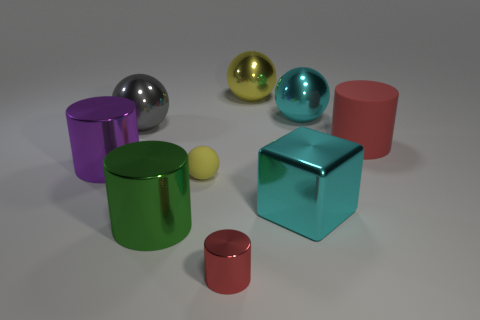Are there fewer red shiny cylinders than big blue shiny cylinders?
Make the answer very short. No. There is a gray ball; does it have the same size as the red cylinder on the left side of the cyan metallic cube?
Your answer should be very brief. No. What color is the ball in front of the cylinder that is on the right side of the big cyan cube?
Your response must be concise. Yellow. What number of objects are purple things that are behind the large cyan block or shiny spheres that are to the left of the block?
Ensure brevity in your answer.  3. Does the purple metallic cylinder have the same size as the cyan ball?
Provide a succinct answer. Yes. Is there any other thing that is the same size as the red metal object?
Ensure brevity in your answer.  Yes. There is a yellow thing in front of the large yellow metallic sphere; is it the same shape as the large cyan metal thing that is behind the gray sphere?
Offer a very short reply. Yes. The rubber cylinder has what size?
Keep it short and to the point. Large. There is a big sphere that is on the left side of the green metal object right of the big metallic ball in front of the cyan metal sphere; what is it made of?
Offer a terse response. Metal. What number of other objects are there of the same color as the tiny ball?
Keep it short and to the point. 1. 